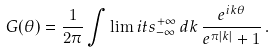Convert formula to latex. <formula><loc_0><loc_0><loc_500><loc_500>G ( \theta ) = \frac { 1 } { 2 \pi } \int \lim i t s _ { - \infty } ^ { + \infty } \, d k \, \frac { e ^ { i k \theta } } { e ^ { \pi | k | } + 1 } \, .</formula> 